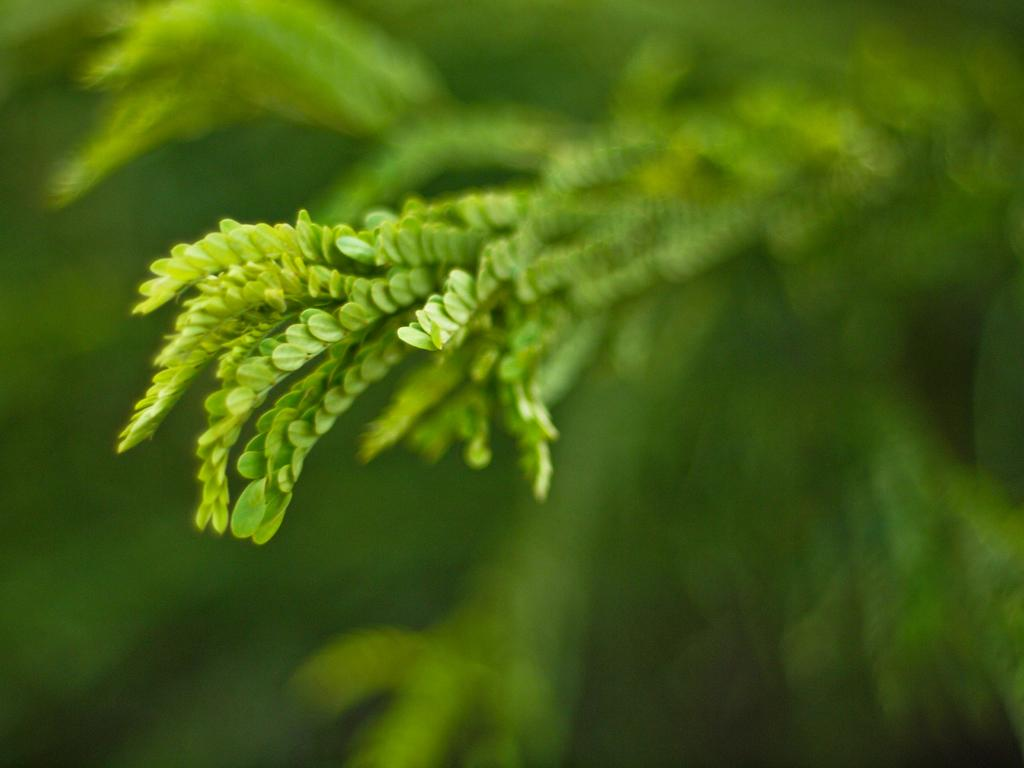What type of natural elements can be seen in the image? There are leaves in the image. Can you describe the background of the image? The background of the image is blurry. What type of cloth is hanging from the icicle in the image? There is no cloth or icicle present in the image; it only features leaves and a blurry background. 